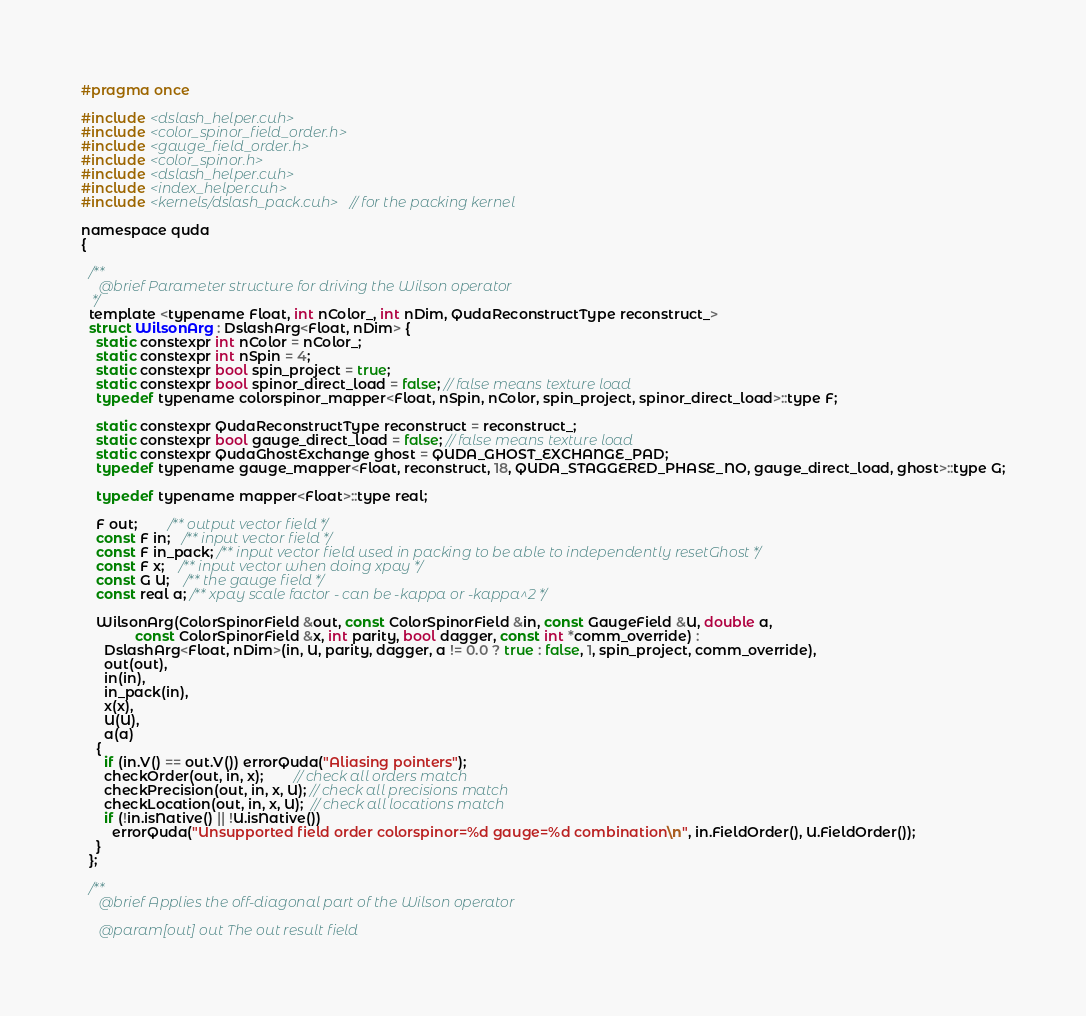<code> <loc_0><loc_0><loc_500><loc_500><_Cuda_>#pragma once

#include <dslash_helper.cuh>
#include <color_spinor_field_order.h>
#include <gauge_field_order.h>
#include <color_spinor.h>
#include <dslash_helper.cuh>
#include <index_helper.cuh>
#include <kernels/dslash_pack.cuh> // for the packing kernel

namespace quda
{

  /**
     @brief Parameter structure for driving the Wilson operator
   */
  template <typename Float, int nColor_, int nDim, QudaReconstructType reconstruct_>
  struct WilsonArg : DslashArg<Float, nDim> {
    static constexpr int nColor = nColor_;
    static constexpr int nSpin = 4;
    static constexpr bool spin_project = true;
    static constexpr bool spinor_direct_load = false; // false means texture load
    typedef typename colorspinor_mapper<Float, nSpin, nColor, spin_project, spinor_direct_load>::type F;

    static constexpr QudaReconstructType reconstruct = reconstruct_;
    static constexpr bool gauge_direct_load = false; // false means texture load
    static constexpr QudaGhostExchange ghost = QUDA_GHOST_EXCHANGE_PAD;
    typedef typename gauge_mapper<Float, reconstruct, 18, QUDA_STAGGERED_PHASE_NO, gauge_direct_load, ghost>::type G;

    typedef typename mapper<Float>::type real;

    F out;        /** output vector field */
    const F in;   /** input vector field */
    const F in_pack; /** input vector field used in packing to be able to independently resetGhost */
    const F x;    /** input vector when doing xpay */
    const G U;    /** the gauge field */
    const real a; /** xpay scale factor - can be -kappa or -kappa^2 */

    WilsonArg(ColorSpinorField &out, const ColorSpinorField &in, const GaugeField &U, double a,
              const ColorSpinorField &x, int parity, bool dagger, const int *comm_override) :
      DslashArg<Float, nDim>(in, U, parity, dagger, a != 0.0 ? true : false, 1, spin_project, comm_override),
      out(out),
      in(in),
      in_pack(in),
      x(x),
      U(U),
      a(a)
    {
      if (in.V() == out.V()) errorQuda("Aliasing pointers");
      checkOrder(out, in, x);        // check all orders match
      checkPrecision(out, in, x, U); // check all precisions match
      checkLocation(out, in, x, U);  // check all locations match
      if (!in.isNative() || !U.isNative())
        errorQuda("Unsupported field order colorspinor=%d gauge=%d combination\n", in.FieldOrder(), U.FieldOrder());
    }
  };

  /**
     @brief Applies the off-diagonal part of the Wilson operator

     @param[out] out The out result field</code> 